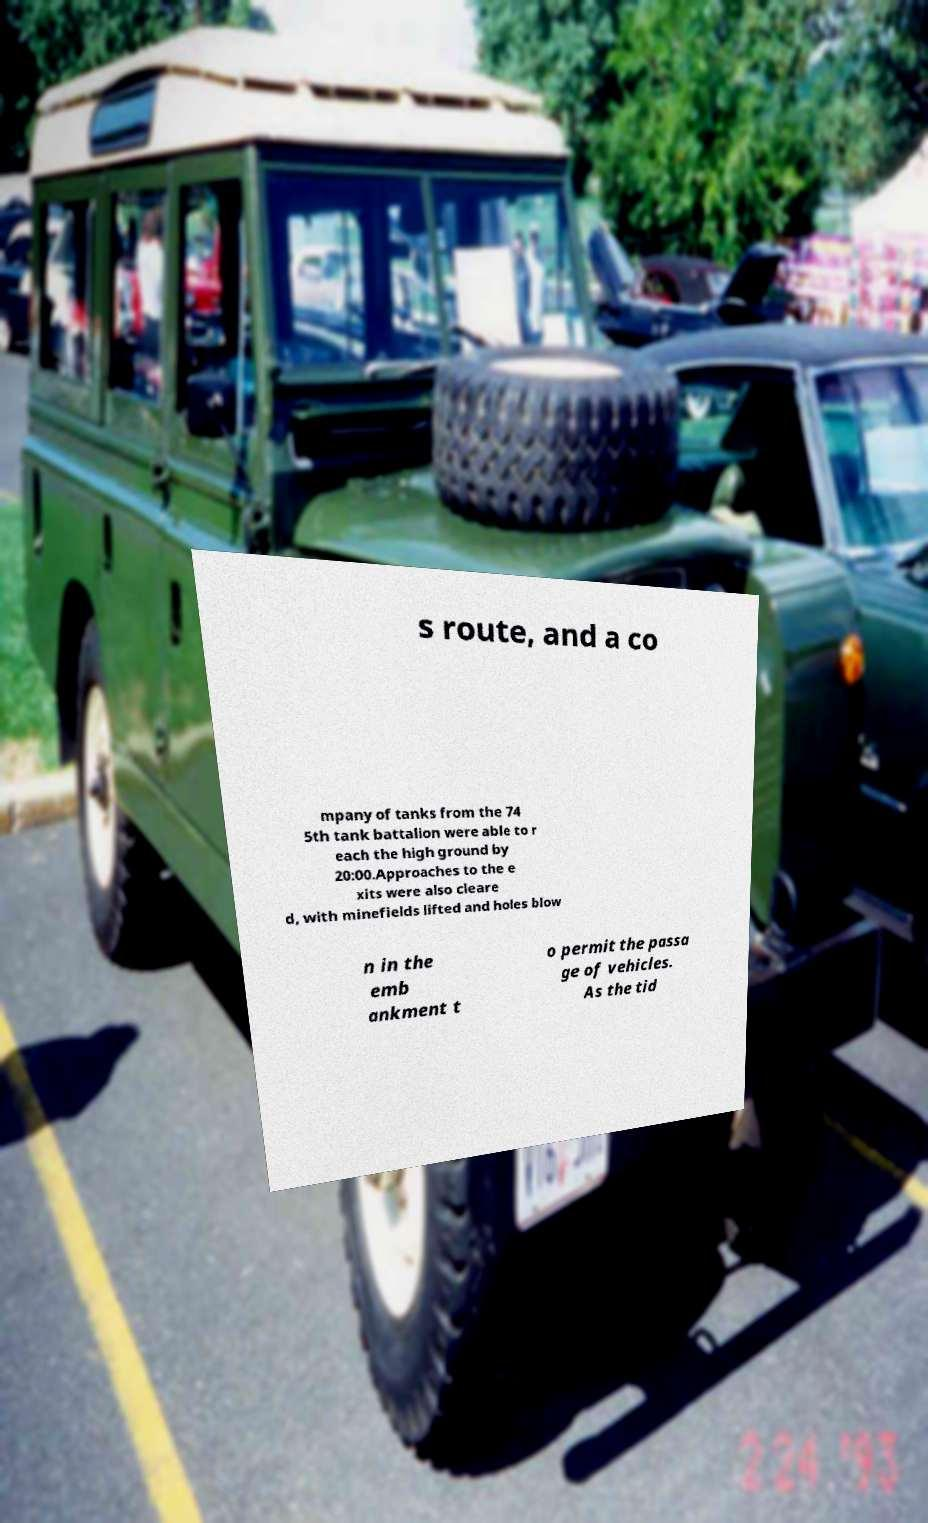Could you assist in decoding the text presented in this image and type it out clearly? s route, and a co mpany of tanks from the 74 5th tank battalion were able to r each the high ground by 20:00.Approaches to the e xits were also cleare d, with minefields lifted and holes blow n in the emb ankment t o permit the passa ge of vehicles. As the tid 